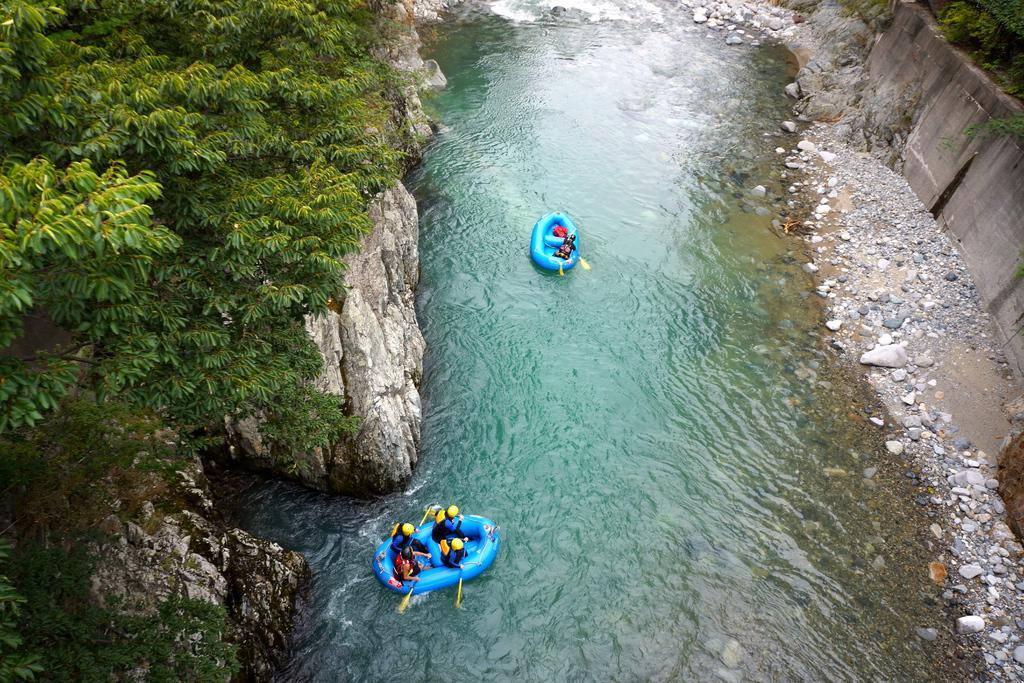Can you describe this image briefly? In this picture we can observe two blue color boats in this lake. We can observe stones. There are some trees. 